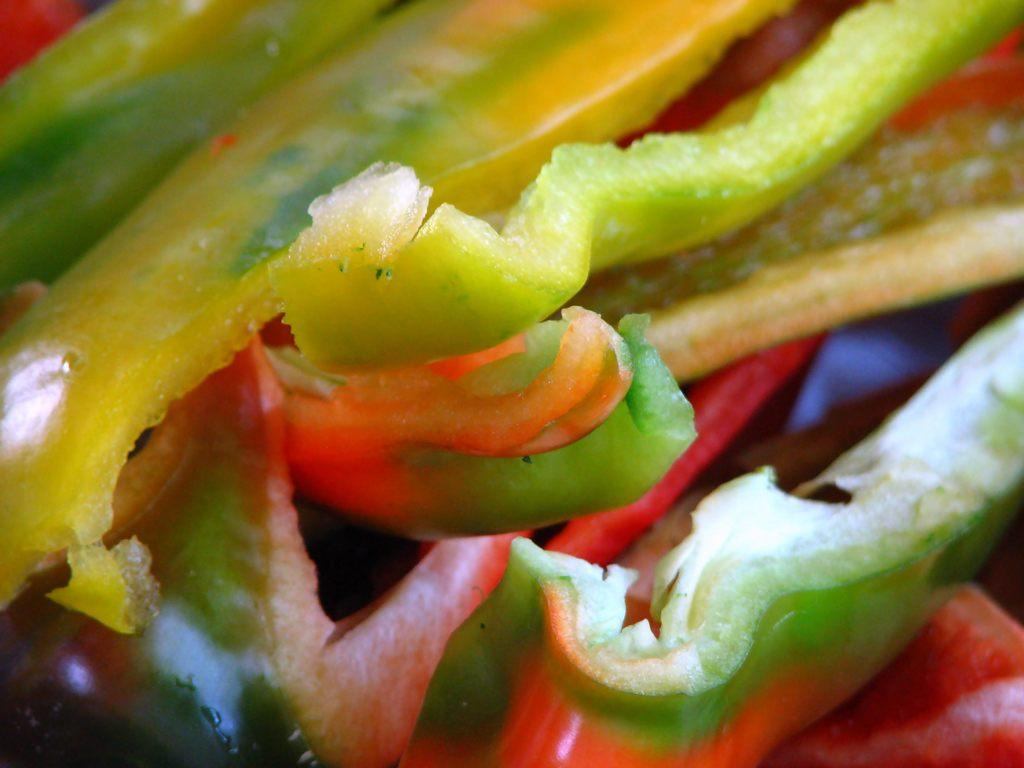What type of food is visible in the image? There are pieces of capsicum in the image. How many bikes are used to make the capsicum in the image? Bikes are not used to make capsicum, nor are they present in the image. Capsicum is a type of vegetable and is not related to bikes. 